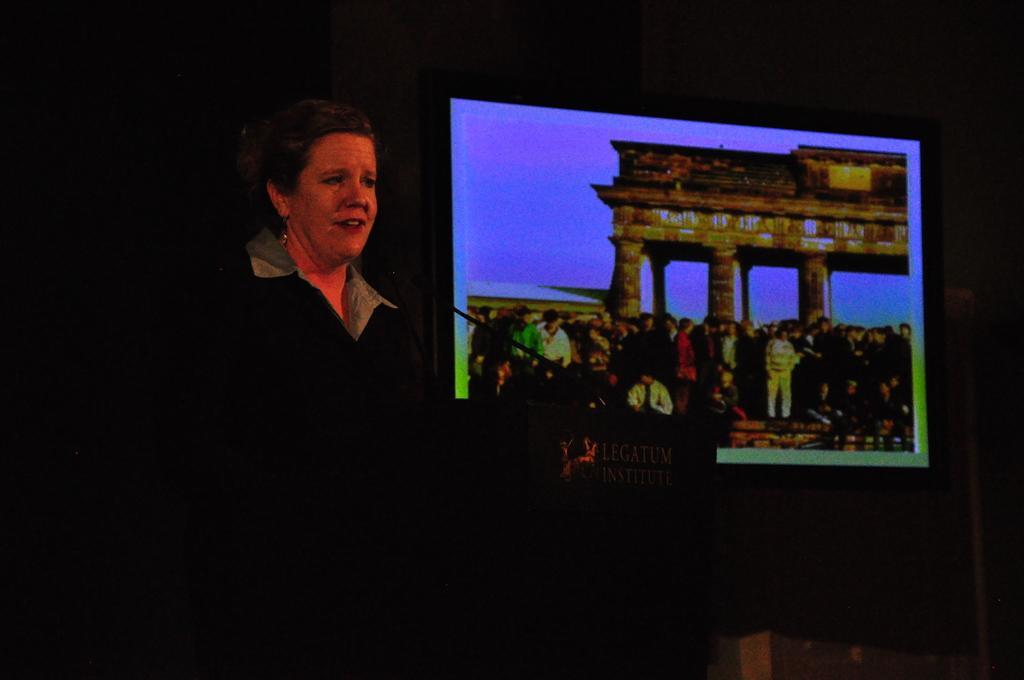In one or two sentences, can you explain what this image depicts? The woman on the left side is standing. In front of her, we see a podium on which microphone is placed and I think she is talking on the microphone. Behind her, we see the projector which is displaying something. In the background, it is black in color. This picture is clicked in the dark. 